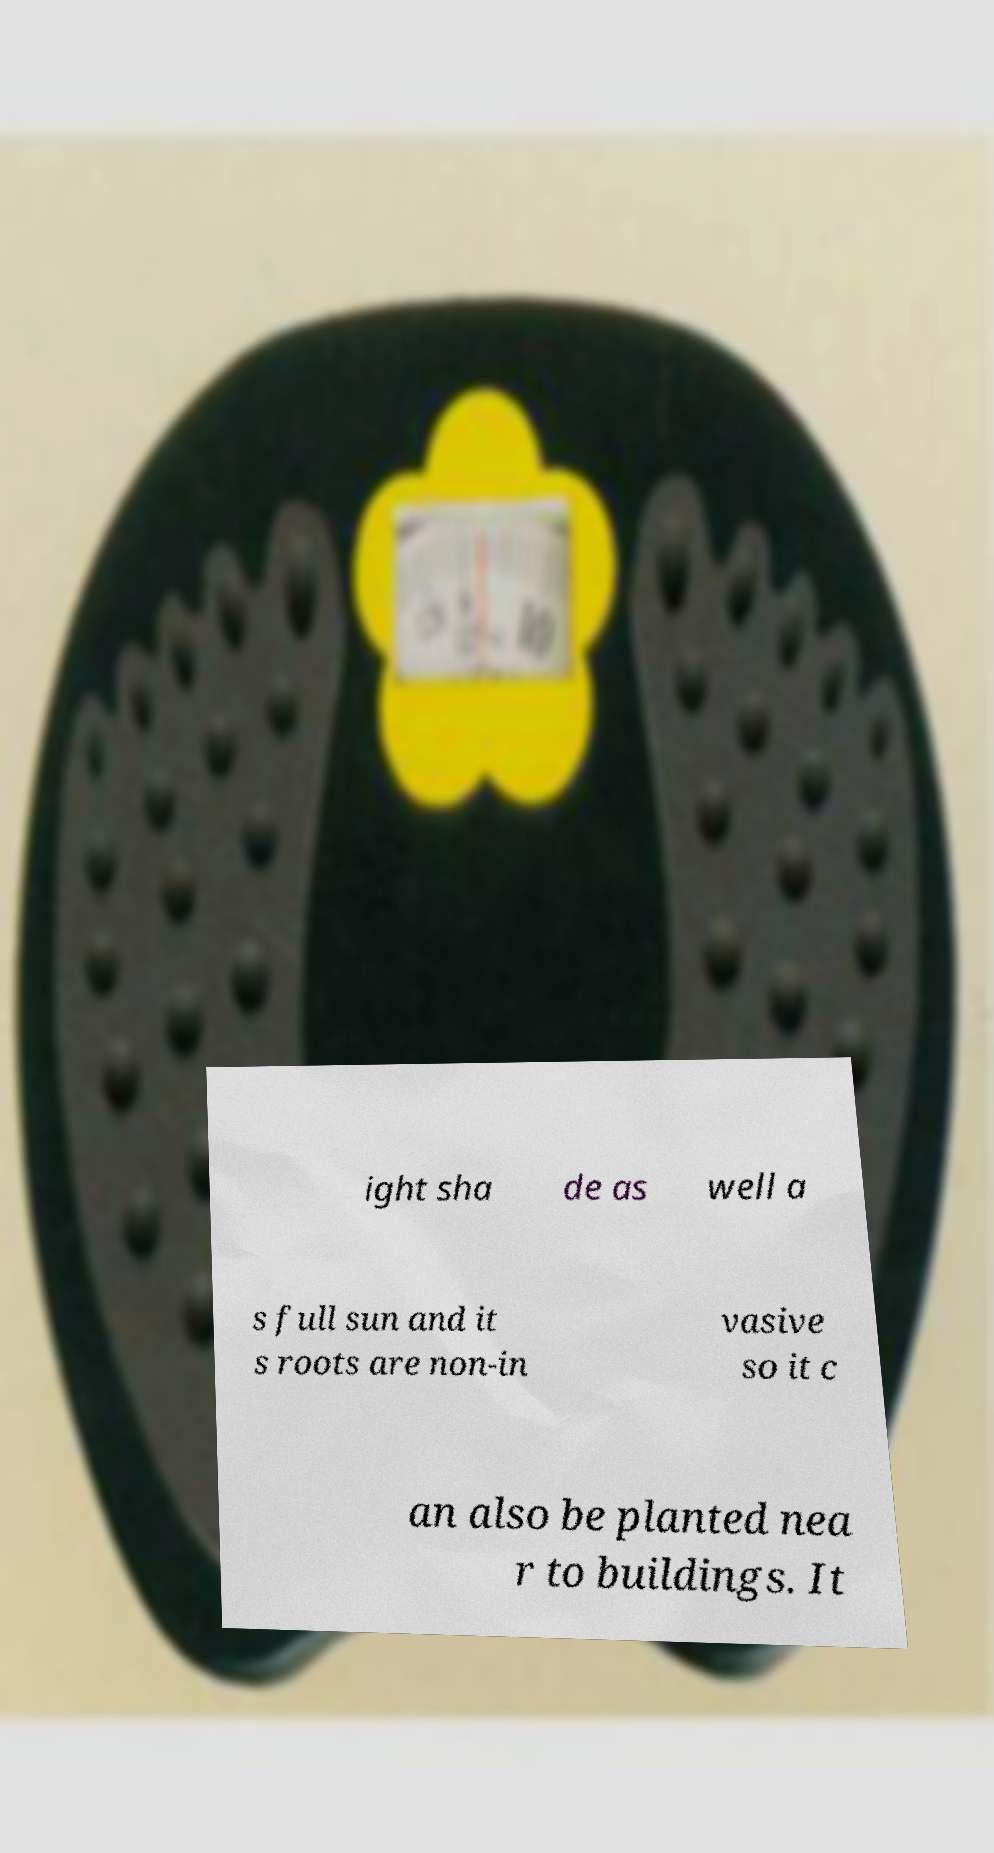Could you extract and type out the text from this image? ight sha de as well a s full sun and it s roots are non-in vasive so it c an also be planted nea r to buildings. It 